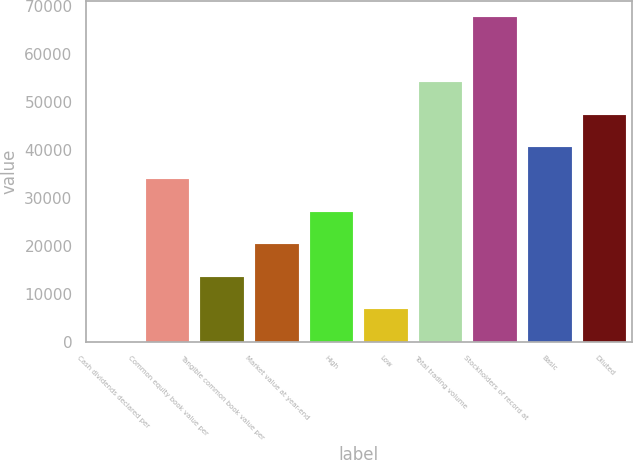<chart> <loc_0><loc_0><loc_500><loc_500><bar_chart><fcel>Cash dividends declared per<fcel>Common equity book value per<fcel>Tangible common book value per<fcel>Market value at year-end<fcel>High<fcel>Low<fcel>Total trading volume<fcel>Stockholders of record at<fcel>Basic<fcel>Diluted<nl><fcel>0.04<fcel>33787<fcel>13514.8<fcel>20272.2<fcel>27029.6<fcel>6757.44<fcel>54059.2<fcel>67574<fcel>40544.4<fcel>47301.8<nl></chart> 